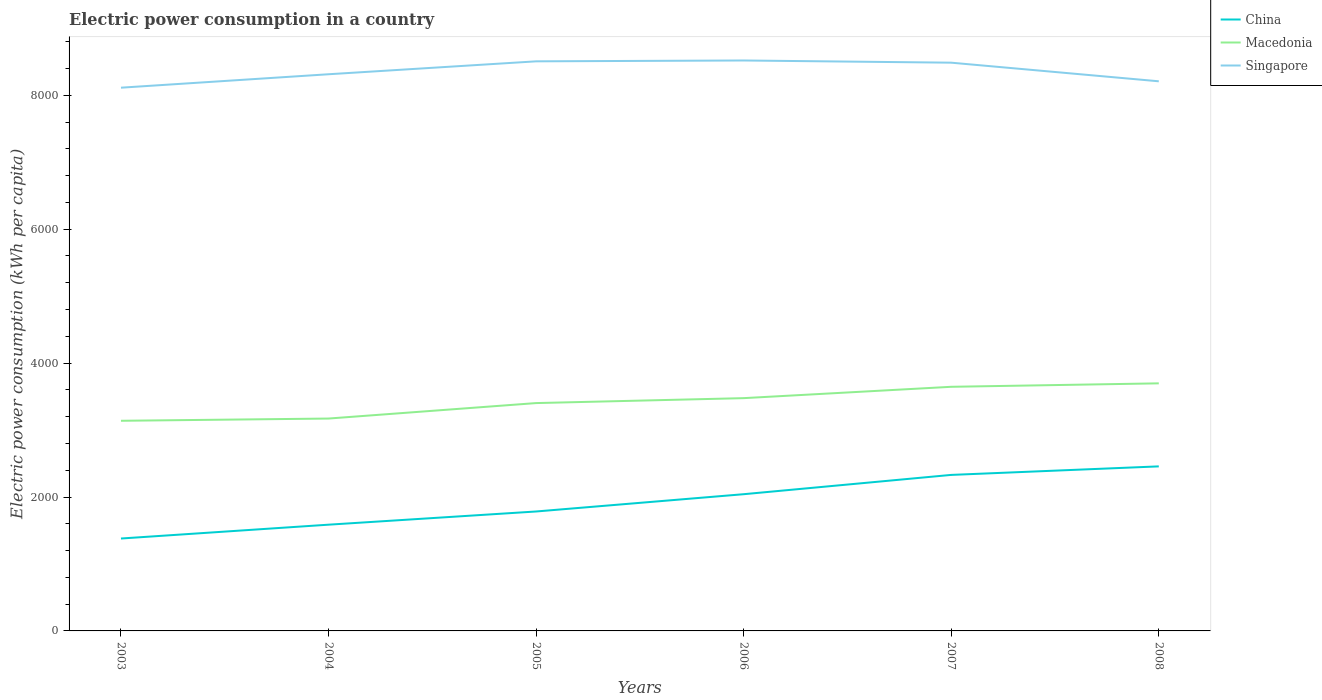Is the number of lines equal to the number of legend labels?
Your response must be concise. Yes. Across all years, what is the maximum electric power consumption in in Macedonia?
Offer a very short reply. 3138.68. What is the total electric power consumption in in Macedonia in the graph?
Your answer should be very brief. -559.14. What is the difference between the highest and the second highest electric power consumption in in Macedonia?
Keep it short and to the point. 559.14. What is the difference between the highest and the lowest electric power consumption in in China?
Keep it short and to the point. 3. Is the electric power consumption in in Singapore strictly greater than the electric power consumption in in China over the years?
Give a very brief answer. No. Are the values on the major ticks of Y-axis written in scientific E-notation?
Offer a terse response. No. Does the graph contain grids?
Your response must be concise. No. How are the legend labels stacked?
Make the answer very short. Vertical. What is the title of the graph?
Provide a short and direct response. Electric power consumption in a country. What is the label or title of the X-axis?
Ensure brevity in your answer.  Years. What is the label or title of the Y-axis?
Ensure brevity in your answer.  Electric power consumption (kWh per capita). What is the Electric power consumption (kWh per capita) in China in 2003?
Ensure brevity in your answer.  1380.2. What is the Electric power consumption (kWh per capita) in Macedonia in 2003?
Offer a terse response. 3138.68. What is the Electric power consumption (kWh per capita) in Singapore in 2003?
Ensure brevity in your answer.  8113.64. What is the Electric power consumption (kWh per capita) in China in 2004?
Keep it short and to the point. 1586.78. What is the Electric power consumption (kWh per capita) in Macedonia in 2004?
Ensure brevity in your answer.  3172.03. What is the Electric power consumption (kWh per capita) of Singapore in 2004?
Your answer should be very brief. 8314.25. What is the Electric power consumption (kWh per capita) in China in 2005?
Provide a short and direct response. 1783.87. What is the Electric power consumption (kWh per capita) in Macedonia in 2005?
Provide a succinct answer. 3403.02. What is the Electric power consumption (kWh per capita) in Singapore in 2005?
Provide a short and direct response. 8507.2. What is the Electric power consumption (kWh per capita) of China in 2006?
Offer a very short reply. 2041.97. What is the Electric power consumption (kWh per capita) of Macedonia in 2006?
Give a very brief answer. 3476.72. What is the Electric power consumption (kWh per capita) of Singapore in 2006?
Give a very brief answer. 8520.02. What is the Electric power consumption (kWh per capita) in China in 2007?
Give a very brief answer. 2330.26. What is the Electric power consumption (kWh per capita) in Macedonia in 2007?
Ensure brevity in your answer.  3646.24. What is the Electric power consumption (kWh per capita) of Singapore in 2007?
Keep it short and to the point. 8487.12. What is the Electric power consumption (kWh per capita) of China in 2008?
Offer a very short reply. 2457.54. What is the Electric power consumption (kWh per capita) in Macedonia in 2008?
Your answer should be compact. 3697.82. What is the Electric power consumption (kWh per capita) of Singapore in 2008?
Keep it short and to the point. 8209.08. Across all years, what is the maximum Electric power consumption (kWh per capita) in China?
Your response must be concise. 2457.54. Across all years, what is the maximum Electric power consumption (kWh per capita) in Macedonia?
Ensure brevity in your answer.  3697.82. Across all years, what is the maximum Electric power consumption (kWh per capita) of Singapore?
Keep it short and to the point. 8520.02. Across all years, what is the minimum Electric power consumption (kWh per capita) of China?
Your response must be concise. 1380.2. Across all years, what is the minimum Electric power consumption (kWh per capita) of Macedonia?
Keep it short and to the point. 3138.68. Across all years, what is the minimum Electric power consumption (kWh per capita) of Singapore?
Your response must be concise. 8113.64. What is the total Electric power consumption (kWh per capita) of China in the graph?
Offer a very short reply. 1.16e+04. What is the total Electric power consumption (kWh per capita) in Macedonia in the graph?
Your answer should be very brief. 2.05e+04. What is the total Electric power consumption (kWh per capita) of Singapore in the graph?
Your answer should be very brief. 5.02e+04. What is the difference between the Electric power consumption (kWh per capita) in China in 2003 and that in 2004?
Keep it short and to the point. -206.58. What is the difference between the Electric power consumption (kWh per capita) in Macedonia in 2003 and that in 2004?
Your answer should be very brief. -33.34. What is the difference between the Electric power consumption (kWh per capita) of Singapore in 2003 and that in 2004?
Provide a succinct answer. -200.61. What is the difference between the Electric power consumption (kWh per capita) in China in 2003 and that in 2005?
Your answer should be compact. -403.67. What is the difference between the Electric power consumption (kWh per capita) in Macedonia in 2003 and that in 2005?
Offer a terse response. -264.33. What is the difference between the Electric power consumption (kWh per capita) of Singapore in 2003 and that in 2005?
Your answer should be compact. -393.56. What is the difference between the Electric power consumption (kWh per capita) in China in 2003 and that in 2006?
Your answer should be compact. -661.77. What is the difference between the Electric power consumption (kWh per capita) in Macedonia in 2003 and that in 2006?
Ensure brevity in your answer.  -338.04. What is the difference between the Electric power consumption (kWh per capita) of Singapore in 2003 and that in 2006?
Offer a terse response. -406.38. What is the difference between the Electric power consumption (kWh per capita) in China in 2003 and that in 2007?
Your answer should be very brief. -950.06. What is the difference between the Electric power consumption (kWh per capita) in Macedonia in 2003 and that in 2007?
Give a very brief answer. -507.56. What is the difference between the Electric power consumption (kWh per capita) in Singapore in 2003 and that in 2007?
Keep it short and to the point. -373.48. What is the difference between the Electric power consumption (kWh per capita) of China in 2003 and that in 2008?
Your response must be concise. -1077.34. What is the difference between the Electric power consumption (kWh per capita) in Macedonia in 2003 and that in 2008?
Make the answer very short. -559.13. What is the difference between the Electric power consumption (kWh per capita) of Singapore in 2003 and that in 2008?
Provide a short and direct response. -95.44. What is the difference between the Electric power consumption (kWh per capita) in China in 2004 and that in 2005?
Give a very brief answer. -197.09. What is the difference between the Electric power consumption (kWh per capita) of Macedonia in 2004 and that in 2005?
Offer a very short reply. -230.99. What is the difference between the Electric power consumption (kWh per capita) of Singapore in 2004 and that in 2005?
Offer a terse response. -192.94. What is the difference between the Electric power consumption (kWh per capita) in China in 2004 and that in 2006?
Provide a short and direct response. -455.19. What is the difference between the Electric power consumption (kWh per capita) in Macedonia in 2004 and that in 2006?
Offer a terse response. -304.7. What is the difference between the Electric power consumption (kWh per capita) in Singapore in 2004 and that in 2006?
Offer a very short reply. -205.76. What is the difference between the Electric power consumption (kWh per capita) in China in 2004 and that in 2007?
Your answer should be very brief. -743.49. What is the difference between the Electric power consumption (kWh per capita) of Macedonia in 2004 and that in 2007?
Give a very brief answer. -474.22. What is the difference between the Electric power consumption (kWh per capita) in Singapore in 2004 and that in 2007?
Keep it short and to the point. -172.87. What is the difference between the Electric power consumption (kWh per capita) of China in 2004 and that in 2008?
Keep it short and to the point. -870.77. What is the difference between the Electric power consumption (kWh per capita) of Macedonia in 2004 and that in 2008?
Your answer should be compact. -525.79. What is the difference between the Electric power consumption (kWh per capita) of Singapore in 2004 and that in 2008?
Provide a short and direct response. 105.18. What is the difference between the Electric power consumption (kWh per capita) of China in 2005 and that in 2006?
Offer a terse response. -258.1. What is the difference between the Electric power consumption (kWh per capita) in Macedonia in 2005 and that in 2006?
Your answer should be compact. -73.71. What is the difference between the Electric power consumption (kWh per capita) in Singapore in 2005 and that in 2006?
Provide a succinct answer. -12.82. What is the difference between the Electric power consumption (kWh per capita) in China in 2005 and that in 2007?
Your answer should be very brief. -546.39. What is the difference between the Electric power consumption (kWh per capita) of Macedonia in 2005 and that in 2007?
Your answer should be compact. -243.23. What is the difference between the Electric power consumption (kWh per capita) in Singapore in 2005 and that in 2007?
Provide a short and direct response. 20.08. What is the difference between the Electric power consumption (kWh per capita) in China in 2005 and that in 2008?
Make the answer very short. -673.67. What is the difference between the Electric power consumption (kWh per capita) of Macedonia in 2005 and that in 2008?
Give a very brief answer. -294.8. What is the difference between the Electric power consumption (kWh per capita) in Singapore in 2005 and that in 2008?
Your answer should be compact. 298.12. What is the difference between the Electric power consumption (kWh per capita) of China in 2006 and that in 2007?
Provide a succinct answer. -288.3. What is the difference between the Electric power consumption (kWh per capita) of Macedonia in 2006 and that in 2007?
Keep it short and to the point. -169.52. What is the difference between the Electric power consumption (kWh per capita) of Singapore in 2006 and that in 2007?
Provide a succinct answer. 32.9. What is the difference between the Electric power consumption (kWh per capita) of China in 2006 and that in 2008?
Provide a succinct answer. -415.58. What is the difference between the Electric power consumption (kWh per capita) in Macedonia in 2006 and that in 2008?
Provide a succinct answer. -221.09. What is the difference between the Electric power consumption (kWh per capita) in Singapore in 2006 and that in 2008?
Offer a very short reply. 310.94. What is the difference between the Electric power consumption (kWh per capita) of China in 2007 and that in 2008?
Offer a very short reply. -127.28. What is the difference between the Electric power consumption (kWh per capita) in Macedonia in 2007 and that in 2008?
Ensure brevity in your answer.  -51.58. What is the difference between the Electric power consumption (kWh per capita) in Singapore in 2007 and that in 2008?
Make the answer very short. 278.04. What is the difference between the Electric power consumption (kWh per capita) of China in 2003 and the Electric power consumption (kWh per capita) of Macedonia in 2004?
Ensure brevity in your answer.  -1791.83. What is the difference between the Electric power consumption (kWh per capita) in China in 2003 and the Electric power consumption (kWh per capita) in Singapore in 2004?
Offer a very short reply. -6934.05. What is the difference between the Electric power consumption (kWh per capita) of Macedonia in 2003 and the Electric power consumption (kWh per capita) of Singapore in 2004?
Your answer should be very brief. -5175.57. What is the difference between the Electric power consumption (kWh per capita) in China in 2003 and the Electric power consumption (kWh per capita) in Macedonia in 2005?
Make the answer very short. -2022.81. What is the difference between the Electric power consumption (kWh per capita) in China in 2003 and the Electric power consumption (kWh per capita) in Singapore in 2005?
Your answer should be very brief. -7127. What is the difference between the Electric power consumption (kWh per capita) in Macedonia in 2003 and the Electric power consumption (kWh per capita) in Singapore in 2005?
Give a very brief answer. -5368.51. What is the difference between the Electric power consumption (kWh per capita) in China in 2003 and the Electric power consumption (kWh per capita) in Macedonia in 2006?
Your answer should be compact. -2096.52. What is the difference between the Electric power consumption (kWh per capita) in China in 2003 and the Electric power consumption (kWh per capita) in Singapore in 2006?
Provide a short and direct response. -7139.82. What is the difference between the Electric power consumption (kWh per capita) in Macedonia in 2003 and the Electric power consumption (kWh per capita) in Singapore in 2006?
Make the answer very short. -5381.33. What is the difference between the Electric power consumption (kWh per capita) in China in 2003 and the Electric power consumption (kWh per capita) in Macedonia in 2007?
Offer a terse response. -2266.04. What is the difference between the Electric power consumption (kWh per capita) of China in 2003 and the Electric power consumption (kWh per capita) of Singapore in 2007?
Your answer should be compact. -7106.92. What is the difference between the Electric power consumption (kWh per capita) of Macedonia in 2003 and the Electric power consumption (kWh per capita) of Singapore in 2007?
Provide a succinct answer. -5348.44. What is the difference between the Electric power consumption (kWh per capita) of China in 2003 and the Electric power consumption (kWh per capita) of Macedonia in 2008?
Provide a short and direct response. -2317.62. What is the difference between the Electric power consumption (kWh per capita) in China in 2003 and the Electric power consumption (kWh per capita) in Singapore in 2008?
Your response must be concise. -6828.87. What is the difference between the Electric power consumption (kWh per capita) in Macedonia in 2003 and the Electric power consumption (kWh per capita) in Singapore in 2008?
Provide a short and direct response. -5070.39. What is the difference between the Electric power consumption (kWh per capita) in China in 2004 and the Electric power consumption (kWh per capita) in Macedonia in 2005?
Make the answer very short. -1816.24. What is the difference between the Electric power consumption (kWh per capita) of China in 2004 and the Electric power consumption (kWh per capita) of Singapore in 2005?
Offer a terse response. -6920.42. What is the difference between the Electric power consumption (kWh per capita) in Macedonia in 2004 and the Electric power consumption (kWh per capita) in Singapore in 2005?
Offer a terse response. -5335.17. What is the difference between the Electric power consumption (kWh per capita) in China in 2004 and the Electric power consumption (kWh per capita) in Macedonia in 2006?
Your answer should be compact. -1889.95. What is the difference between the Electric power consumption (kWh per capita) in China in 2004 and the Electric power consumption (kWh per capita) in Singapore in 2006?
Keep it short and to the point. -6933.24. What is the difference between the Electric power consumption (kWh per capita) of Macedonia in 2004 and the Electric power consumption (kWh per capita) of Singapore in 2006?
Ensure brevity in your answer.  -5347.99. What is the difference between the Electric power consumption (kWh per capita) in China in 2004 and the Electric power consumption (kWh per capita) in Macedonia in 2007?
Your response must be concise. -2059.47. What is the difference between the Electric power consumption (kWh per capita) of China in 2004 and the Electric power consumption (kWh per capita) of Singapore in 2007?
Give a very brief answer. -6900.34. What is the difference between the Electric power consumption (kWh per capita) in Macedonia in 2004 and the Electric power consumption (kWh per capita) in Singapore in 2007?
Your answer should be very brief. -5315.09. What is the difference between the Electric power consumption (kWh per capita) of China in 2004 and the Electric power consumption (kWh per capita) of Macedonia in 2008?
Your answer should be very brief. -2111.04. What is the difference between the Electric power consumption (kWh per capita) in China in 2004 and the Electric power consumption (kWh per capita) in Singapore in 2008?
Give a very brief answer. -6622.3. What is the difference between the Electric power consumption (kWh per capita) of Macedonia in 2004 and the Electric power consumption (kWh per capita) of Singapore in 2008?
Offer a very short reply. -5037.05. What is the difference between the Electric power consumption (kWh per capita) in China in 2005 and the Electric power consumption (kWh per capita) in Macedonia in 2006?
Ensure brevity in your answer.  -1692.85. What is the difference between the Electric power consumption (kWh per capita) of China in 2005 and the Electric power consumption (kWh per capita) of Singapore in 2006?
Ensure brevity in your answer.  -6736.15. What is the difference between the Electric power consumption (kWh per capita) of Macedonia in 2005 and the Electric power consumption (kWh per capita) of Singapore in 2006?
Ensure brevity in your answer.  -5117. What is the difference between the Electric power consumption (kWh per capita) in China in 2005 and the Electric power consumption (kWh per capita) in Macedonia in 2007?
Offer a terse response. -1862.37. What is the difference between the Electric power consumption (kWh per capita) in China in 2005 and the Electric power consumption (kWh per capita) in Singapore in 2007?
Give a very brief answer. -6703.25. What is the difference between the Electric power consumption (kWh per capita) in Macedonia in 2005 and the Electric power consumption (kWh per capita) in Singapore in 2007?
Ensure brevity in your answer.  -5084.1. What is the difference between the Electric power consumption (kWh per capita) of China in 2005 and the Electric power consumption (kWh per capita) of Macedonia in 2008?
Offer a very short reply. -1913.95. What is the difference between the Electric power consumption (kWh per capita) in China in 2005 and the Electric power consumption (kWh per capita) in Singapore in 2008?
Make the answer very short. -6425.2. What is the difference between the Electric power consumption (kWh per capita) in Macedonia in 2005 and the Electric power consumption (kWh per capita) in Singapore in 2008?
Provide a succinct answer. -4806.06. What is the difference between the Electric power consumption (kWh per capita) of China in 2006 and the Electric power consumption (kWh per capita) of Macedonia in 2007?
Ensure brevity in your answer.  -1604.28. What is the difference between the Electric power consumption (kWh per capita) in China in 2006 and the Electric power consumption (kWh per capita) in Singapore in 2007?
Keep it short and to the point. -6445.15. What is the difference between the Electric power consumption (kWh per capita) of Macedonia in 2006 and the Electric power consumption (kWh per capita) of Singapore in 2007?
Your response must be concise. -5010.4. What is the difference between the Electric power consumption (kWh per capita) in China in 2006 and the Electric power consumption (kWh per capita) in Macedonia in 2008?
Offer a very short reply. -1655.85. What is the difference between the Electric power consumption (kWh per capita) of China in 2006 and the Electric power consumption (kWh per capita) of Singapore in 2008?
Keep it short and to the point. -6167.11. What is the difference between the Electric power consumption (kWh per capita) of Macedonia in 2006 and the Electric power consumption (kWh per capita) of Singapore in 2008?
Provide a short and direct response. -4732.35. What is the difference between the Electric power consumption (kWh per capita) in China in 2007 and the Electric power consumption (kWh per capita) in Macedonia in 2008?
Offer a terse response. -1367.56. What is the difference between the Electric power consumption (kWh per capita) of China in 2007 and the Electric power consumption (kWh per capita) of Singapore in 2008?
Your answer should be very brief. -5878.81. What is the difference between the Electric power consumption (kWh per capita) in Macedonia in 2007 and the Electric power consumption (kWh per capita) in Singapore in 2008?
Your answer should be very brief. -4562.83. What is the average Electric power consumption (kWh per capita) of China per year?
Ensure brevity in your answer.  1930.1. What is the average Electric power consumption (kWh per capita) of Macedonia per year?
Your response must be concise. 3422.42. What is the average Electric power consumption (kWh per capita) of Singapore per year?
Offer a terse response. 8358.55. In the year 2003, what is the difference between the Electric power consumption (kWh per capita) of China and Electric power consumption (kWh per capita) of Macedonia?
Provide a succinct answer. -1758.48. In the year 2003, what is the difference between the Electric power consumption (kWh per capita) in China and Electric power consumption (kWh per capita) in Singapore?
Provide a succinct answer. -6733.44. In the year 2003, what is the difference between the Electric power consumption (kWh per capita) in Macedonia and Electric power consumption (kWh per capita) in Singapore?
Keep it short and to the point. -4974.96. In the year 2004, what is the difference between the Electric power consumption (kWh per capita) of China and Electric power consumption (kWh per capita) of Macedonia?
Provide a succinct answer. -1585.25. In the year 2004, what is the difference between the Electric power consumption (kWh per capita) of China and Electric power consumption (kWh per capita) of Singapore?
Your response must be concise. -6727.48. In the year 2004, what is the difference between the Electric power consumption (kWh per capita) in Macedonia and Electric power consumption (kWh per capita) in Singapore?
Provide a short and direct response. -5142.23. In the year 2005, what is the difference between the Electric power consumption (kWh per capita) in China and Electric power consumption (kWh per capita) in Macedonia?
Ensure brevity in your answer.  -1619.14. In the year 2005, what is the difference between the Electric power consumption (kWh per capita) in China and Electric power consumption (kWh per capita) in Singapore?
Your answer should be very brief. -6723.33. In the year 2005, what is the difference between the Electric power consumption (kWh per capita) of Macedonia and Electric power consumption (kWh per capita) of Singapore?
Provide a succinct answer. -5104.18. In the year 2006, what is the difference between the Electric power consumption (kWh per capita) of China and Electric power consumption (kWh per capita) of Macedonia?
Offer a very short reply. -1434.76. In the year 2006, what is the difference between the Electric power consumption (kWh per capita) of China and Electric power consumption (kWh per capita) of Singapore?
Ensure brevity in your answer.  -6478.05. In the year 2006, what is the difference between the Electric power consumption (kWh per capita) in Macedonia and Electric power consumption (kWh per capita) in Singapore?
Your response must be concise. -5043.29. In the year 2007, what is the difference between the Electric power consumption (kWh per capita) in China and Electric power consumption (kWh per capita) in Macedonia?
Your answer should be very brief. -1315.98. In the year 2007, what is the difference between the Electric power consumption (kWh per capita) of China and Electric power consumption (kWh per capita) of Singapore?
Your answer should be compact. -6156.86. In the year 2007, what is the difference between the Electric power consumption (kWh per capita) in Macedonia and Electric power consumption (kWh per capita) in Singapore?
Your response must be concise. -4840.88. In the year 2008, what is the difference between the Electric power consumption (kWh per capita) of China and Electric power consumption (kWh per capita) of Macedonia?
Keep it short and to the point. -1240.27. In the year 2008, what is the difference between the Electric power consumption (kWh per capita) in China and Electric power consumption (kWh per capita) in Singapore?
Provide a short and direct response. -5751.53. In the year 2008, what is the difference between the Electric power consumption (kWh per capita) of Macedonia and Electric power consumption (kWh per capita) of Singapore?
Your response must be concise. -4511.26. What is the ratio of the Electric power consumption (kWh per capita) in China in 2003 to that in 2004?
Offer a very short reply. 0.87. What is the ratio of the Electric power consumption (kWh per capita) in Macedonia in 2003 to that in 2004?
Your response must be concise. 0.99. What is the ratio of the Electric power consumption (kWh per capita) of Singapore in 2003 to that in 2004?
Give a very brief answer. 0.98. What is the ratio of the Electric power consumption (kWh per capita) of China in 2003 to that in 2005?
Your response must be concise. 0.77. What is the ratio of the Electric power consumption (kWh per capita) of Macedonia in 2003 to that in 2005?
Keep it short and to the point. 0.92. What is the ratio of the Electric power consumption (kWh per capita) in Singapore in 2003 to that in 2005?
Your answer should be compact. 0.95. What is the ratio of the Electric power consumption (kWh per capita) of China in 2003 to that in 2006?
Give a very brief answer. 0.68. What is the ratio of the Electric power consumption (kWh per capita) of Macedonia in 2003 to that in 2006?
Offer a very short reply. 0.9. What is the ratio of the Electric power consumption (kWh per capita) of Singapore in 2003 to that in 2006?
Give a very brief answer. 0.95. What is the ratio of the Electric power consumption (kWh per capita) of China in 2003 to that in 2007?
Give a very brief answer. 0.59. What is the ratio of the Electric power consumption (kWh per capita) in Macedonia in 2003 to that in 2007?
Your answer should be compact. 0.86. What is the ratio of the Electric power consumption (kWh per capita) in Singapore in 2003 to that in 2007?
Offer a terse response. 0.96. What is the ratio of the Electric power consumption (kWh per capita) of China in 2003 to that in 2008?
Keep it short and to the point. 0.56. What is the ratio of the Electric power consumption (kWh per capita) in Macedonia in 2003 to that in 2008?
Provide a succinct answer. 0.85. What is the ratio of the Electric power consumption (kWh per capita) of Singapore in 2003 to that in 2008?
Offer a terse response. 0.99. What is the ratio of the Electric power consumption (kWh per capita) of China in 2004 to that in 2005?
Your answer should be compact. 0.89. What is the ratio of the Electric power consumption (kWh per capita) of Macedonia in 2004 to that in 2005?
Your response must be concise. 0.93. What is the ratio of the Electric power consumption (kWh per capita) of Singapore in 2004 to that in 2005?
Provide a short and direct response. 0.98. What is the ratio of the Electric power consumption (kWh per capita) of China in 2004 to that in 2006?
Ensure brevity in your answer.  0.78. What is the ratio of the Electric power consumption (kWh per capita) of Macedonia in 2004 to that in 2006?
Keep it short and to the point. 0.91. What is the ratio of the Electric power consumption (kWh per capita) of Singapore in 2004 to that in 2006?
Offer a terse response. 0.98. What is the ratio of the Electric power consumption (kWh per capita) in China in 2004 to that in 2007?
Provide a short and direct response. 0.68. What is the ratio of the Electric power consumption (kWh per capita) of Macedonia in 2004 to that in 2007?
Provide a short and direct response. 0.87. What is the ratio of the Electric power consumption (kWh per capita) in Singapore in 2004 to that in 2007?
Your answer should be compact. 0.98. What is the ratio of the Electric power consumption (kWh per capita) of China in 2004 to that in 2008?
Provide a succinct answer. 0.65. What is the ratio of the Electric power consumption (kWh per capita) of Macedonia in 2004 to that in 2008?
Your answer should be compact. 0.86. What is the ratio of the Electric power consumption (kWh per capita) in Singapore in 2004 to that in 2008?
Your answer should be compact. 1.01. What is the ratio of the Electric power consumption (kWh per capita) in China in 2005 to that in 2006?
Your answer should be compact. 0.87. What is the ratio of the Electric power consumption (kWh per capita) of Macedonia in 2005 to that in 2006?
Give a very brief answer. 0.98. What is the ratio of the Electric power consumption (kWh per capita) of Singapore in 2005 to that in 2006?
Ensure brevity in your answer.  1. What is the ratio of the Electric power consumption (kWh per capita) of China in 2005 to that in 2007?
Your answer should be compact. 0.77. What is the ratio of the Electric power consumption (kWh per capita) in Macedonia in 2005 to that in 2007?
Offer a very short reply. 0.93. What is the ratio of the Electric power consumption (kWh per capita) of China in 2005 to that in 2008?
Offer a terse response. 0.73. What is the ratio of the Electric power consumption (kWh per capita) in Macedonia in 2005 to that in 2008?
Provide a succinct answer. 0.92. What is the ratio of the Electric power consumption (kWh per capita) of Singapore in 2005 to that in 2008?
Your answer should be compact. 1.04. What is the ratio of the Electric power consumption (kWh per capita) of China in 2006 to that in 2007?
Your answer should be compact. 0.88. What is the ratio of the Electric power consumption (kWh per capita) in Macedonia in 2006 to that in 2007?
Offer a terse response. 0.95. What is the ratio of the Electric power consumption (kWh per capita) in China in 2006 to that in 2008?
Provide a short and direct response. 0.83. What is the ratio of the Electric power consumption (kWh per capita) in Macedonia in 2006 to that in 2008?
Offer a very short reply. 0.94. What is the ratio of the Electric power consumption (kWh per capita) in Singapore in 2006 to that in 2008?
Provide a succinct answer. 1.04. What is the ratio of the Electric power consumption (kWh per capita) in China in 2007 to that in 2008?
Provide a short and direct response. 0.95. What is the ratio of the Electric power consumption (kWh per capita) in Macedonia in 2007 to that in 2008?
Provide a short and direct response. 0.99. What is the ratio of the Electric power consumption (kWh per capita) of Singapore in 2007 to that in 2008?
Make the answer very short. 1.03. What is the difference between the highest and the second highest Electric power consumption (kWh per capita) of China?
Keep it short and to the point. 127.28. What is the difference between the highest and the second highest Electric power consumption (kWh per capita) of Macedonia?
Keep it short and to the point. 51.58. What is the difference between the highest and the second highest Electric power consumption (kWh per capita) of Singapore?
Offer a terse response. 12.82. What is the difference between the highest and the lowest Electric power consumption (kWh per capita) in China?
Ensure brevity in your answer.  1077.34. What is the difference between the highest and the lowest Electric power consumption (kWh per capita) of Macedonia?
Make the answer very short. 559.13. What is the difference between the highest and the lowest Electric power consumption (kWh per capita) in Singapore?
Offer a terse response. 406.38. 